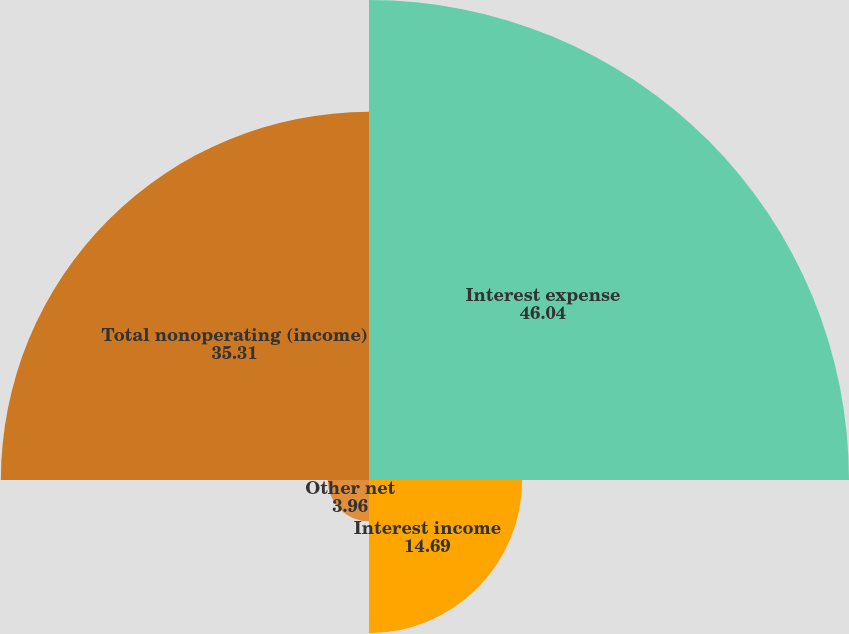Convert chart to OTSL. <chart><loc_0><loc_0><loc_500><loc_500><pie_chart><fcel>Interest expense<fcel>Interest income<fcel>Other net<fcel>Total nonoperating (income)<nl><fcel>46.04%<fcel>14.69%<fcel>3.96%<fcel>35.31%<nl></chart> 